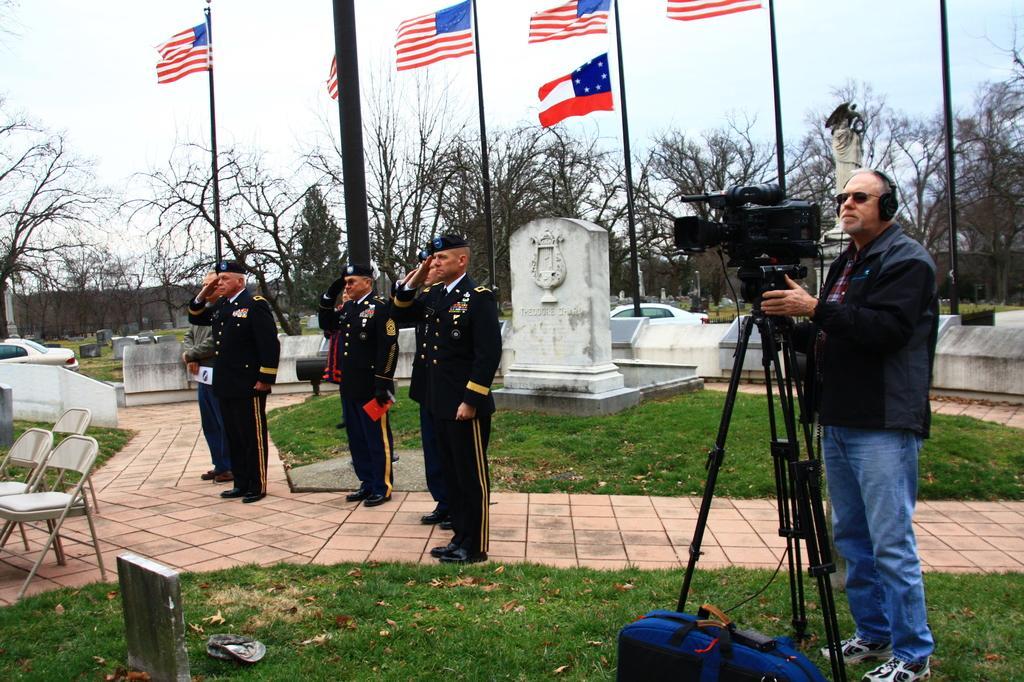How would you summarize this image in a sentence or two? In this picture we can see a few people standing on a path. We can see a bag, footwear, dry leaves and a stone is visible on the grass. There is a person wearing a headset and holding a camera. We can see a few chairs on the left side. There is a vehicle, graves, poles, flags and trees in the background. 